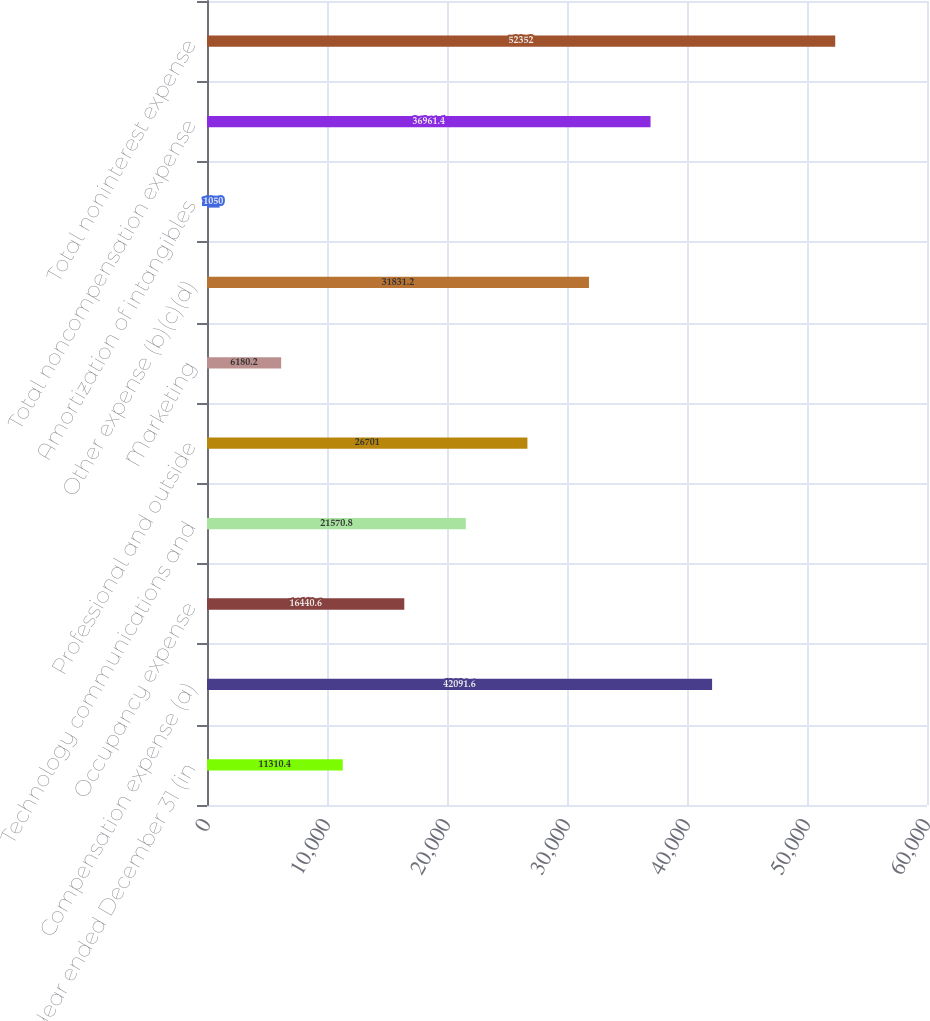Convert chart to OTSL. <chart><loc_0><loc_0><loc_500><loc_500><bar_chart><fcel>Year ended December 31 (in<fcel>Compensation expense (a)<fcel>Occupancy expense<fcel>Technology communications and<fcel>Professional and outside<fcel>Marketing<fcel>Other expense (b)(c)(d)<fcel>Amortization of intangibles<fcel>Total noncompensation expense<fcel>Total noninterest expense<nl><fcel>11310.4<fcel>42091.6<fcel>16440.6<fcel>21570.8<fcel>26701<fcel>6180.2<fcel>31831.2<fcel>1050<fcel>36961.4<fcel>52352<nl></chart> 